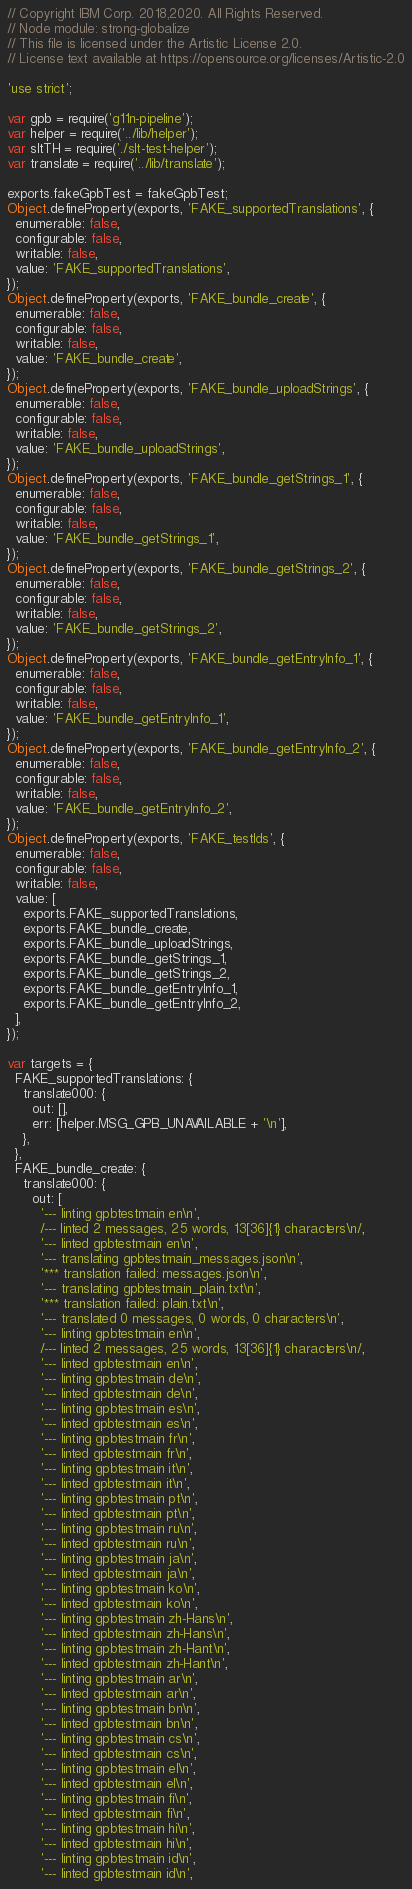<code> <loc_0><loc_0><loc_500><loc_500><_JavaScript_>// Copyright IBM Corp. 2018,2020. All Rights Reserved.
// Node module: strong-globalize
// This file is licensed under the Artistic License 2.0.
// License text available at https://opensource.org/licenses/Artistic-2.0

'use strict';

var gpb = require('g11n-pipeline');
var helper = require('../lib/helper');
var sltTH = require('./slt-test-helper');
var translate = require('../lib/translate');

exports.fakeGpbTest = fakeGpbTest;
Object.defineProperty(exports, 'FAKE_supportedTranslations', {
  enumerable: false,
  configurable: false,
  writable: false,
  value: 'FAKE_supportedTranslations',
});
Object.defineProperty(exports, 'FAKE_bundle_create', {
  enumerable: false,
  configurable: false,
  writable: false,
  value: 'FAKE_bundle_create',
});
Object.defineProperty(exports, 'FAKE_bundle_uploadStrings', {
  enumerable: false,
  configurable: false,
  writable: false,
  value: 'FAKE_bundle_uploadStrings',
});
Object.defineProperty(exports, 'FAKE_bundle_getStrings_1', {
  enumerable: false,
  configurable: false,
  writable: false,
  value: 'FAKE_bundle_getStrings_1',
});
Object.defineProperty(exports, 'FAKE_bundle_getStrings_2', {
  enumerable: false,
  configurable: false,
  writable: false,
  value: 'FAKE_bundle_getStrings_2',
});
Object.defineProperty(exports, 'FAKE_bundle_getEntryInfo_1', {
  enumerable: false,
  configurable: false,
  writable: false,
  value: 'FAKE_bundle_getEntryInfo_1',
});
Object.defineProperty(exports, 'FAKE_bundle_getEntryInfo_2', {
  enumerable: false,
  configurable: false,
  writable: false,
  value: 'FAKE_bundle_getEntryInfo_2',
});
Object.defineProperty(exports, 'FAKE_testIds', {
  enumerable: false,
  configurable: false,
  writable: false,
  value: [
    exports.FAKE_supportedTranslations,
    exports.FAKE_bundle_create,
    exports.FAKE_bundle_uploadStrings,
    exports.FAKE_bundle_getStrings_1,
    exports.FAKE_bundle_getStrings_2,
    exports.FAKE_bundle_getEntryInfo_1,
    exports.FAKE_bundle_getEntryInfo_2,
  ],
});

var targets = {
  FAKE_supportedTranslations: {
    translate000: {
      out: [],
      err: [helper.MSG_GPB_UNAVAILABLE + '\n'],
    },
  },
  FAKE_bundle_create: {
    translate000: {
      out: [
        '--- linting gpbtestmain en\n',
        /--- linted 2 messages, 25 words, 13[36]{1} characters\n/,
        '--- linted gpbtestmain en\n',
        '--- translating gpbtestmain_messages.json\n',
        '*** translation failed: messages.json\n',
        '--- translating gpbtestmain_plain.txt\n',
        '*** translation failed: plain.txt\n',
        '--- translated 0 messages, 0 words, 0 characters\n',
        '--- linting gpbtestmain en\n',
        /--- linted 2 messages, 25 words, 13[36]{1} characters\n/,
        '--- linted gpbtestmain en\n',
        '--- linting gpbtestmain de\n',
        '--- linted gpbtestmain de\n',
        '--- linting gpbtestmain es\n',
        '--- linted gpbtestmain es\n',
        '--- linting gpbtestmain fr\n',
        '--- linted gpbtestmain fr\n',
        '--- linting gpbtestmain it\n',
        '--- linted gpbtestmain it\n',
        '--- linting gpbtestmain pt\n',
        '--- linted gpbtestmain pt\n',
        '--- linting gpbtestmain ru\n',
        '--- linted gpbtestmain ru\n',
        '--- linting gpbtestmain ja\n',
        '--- linted gpbtestmain ja\n',
        '--- linting gpbtestmain ko\n',
        '--- linted gpbtestmain ko\n',
        '--- linting gpbtestmain zh-Hans\n',
        '--- linted gpbtestmain zh-Hans\n',
        '--- linting gpbtestmain zh-Hant\n',
        '--- linted gpbtestmain zh-Hant\n',
        '--- linting gpbtestmain ar\n',
        '--- linted gpbtestmain ar\n',
        '--- linting gpbtestmain bn\n',
        '--- linted gpbtestmain bn\n',
        '--- linting gpbtestmain cs\n',
        '--- linted gpbtestmain cs\n',
        '--- linting gpbtestmain el\n',
        '--- linted gpbtestmain el\n',
        '--- linting gpbtestmain fi\n',
        '--- linted gpbtestmain fi\n',
        '--- linting gpbtestmain hi\n',
        '--- linted gpbtestmain hi\n',
        '--- linting gpbtestmain id\n',
        '--- linted gpbtestmain id\n',</code> 